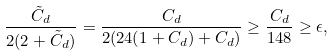<formula> <loc_0><loc_0><loc_500><loc_500>\frac { \tilde { C } _ { d } } { 2 ( 2 + \tilde { C } _ { d } ) } = \frac { C _ { d } } { 2 ( 2 4 ( 1 + C _ { d } ) + C _ { d } ) } \geq \frac { C _ { d } } { 1 4 8 } \geq \epsilon ,</formula> 